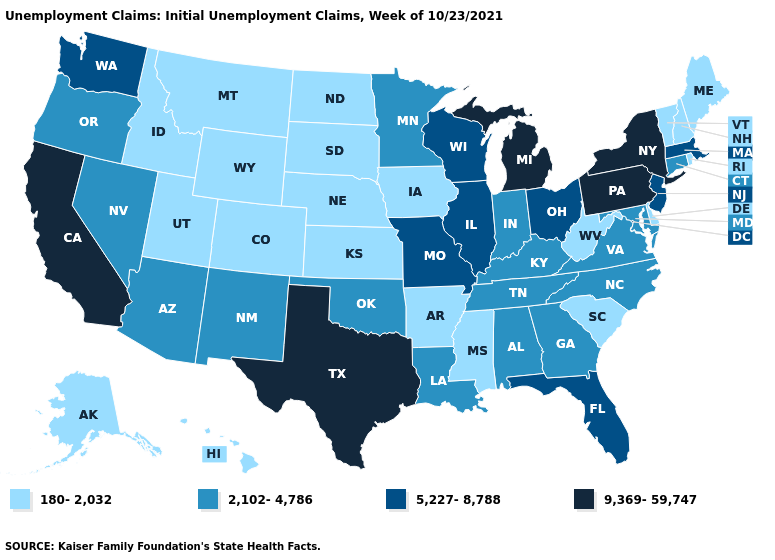What is the value of New Jersey?
Concise answer only. 5,227-8,788. What is the value of Indiana?
Concise answer only. 2,102-4,786. What is the value of Mississippi?
Keep it brief. 180-2,032. How many symbols are there in the legend?
Keep it brief. 4. What is the lowest value in states that border South Dakota?
Concise answer only. 180-2,032. Name the states that have a value in the range 180-2,032?
Short answer required. Alaska, Arkansas, Colorado, Delaware, Hawaii, Idaho, Iowa, Kansas, Maine, Mississippi, Montana, Nebraska, New Hampshire, North Dakota, Rhode Island, South Carolina, South Dakota, Utah, Vermont, West Virginia, Wyoming. Name the states that have a value in the range 2,102-4,786?
Write a very short answer. Alabama, Arizona, Connecticut, Georgia, Indiana, Kentucky, Louisiana, Maryland, Minnesota, Nevada, New Mexico, North Carolina, Oklahoma, Oregon, Tennessee, Virginia. Name the states that have a value in the range 2,102-4,786?
Be succinct. Alabama, Arizona, Connecticut, Georgia, Indiana, Kentucky, Louisiana, Maryland, Minnesota, Nevada, New Mexico, North Carolina, Oklahoma, Oregon, Tennessee, Virginia. Does Georgia have the highest value in the USA?
Give a very brief answer. No. Does Arkansas have a higher value than Montana?
Short answer required. No. Is the legend a continuous bar?
Give a very brief answer. No. Does Illinois have a higher value than North Carolina?
Keep it brief. Yes. Does Louisiana have the same value as California?
Short answer required. No. 